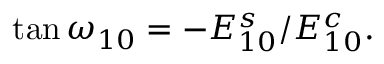<formula> <loc_0><loc_0><loc_500><loc_500>\tan \omega _ { 1 0 } = - E _ { 1 0 } ^ { s } / E _ { 1 0 } ^ { c } .</formula> 